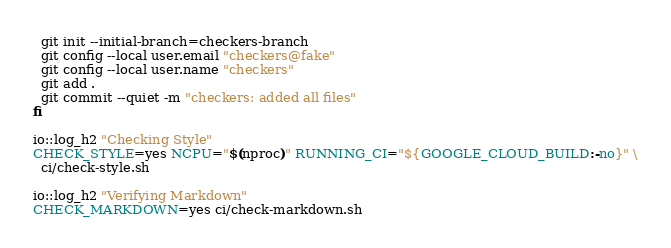Convert code to text. <code><loc_0><loc_0><loc_500><loc_500><_Bash_>  git init --initial-branch=checkers-branch
  git config --local user.email "checkers@fake"
  git config --local user.name "checkers"
  git add .
  git commit --quiet -m "checkers: added all files"
fi

io::log_h2 "Checking Style"
CHECK_STYLE=yes NCPU="$(nproc)" RUNNING_CI="${GOOGLE_CLOUD_BUILD:-no}" \
  ci/check-style.sh

io::log_h2 "Verifying Markdown"
CHECK_MARKDOWN=yes ci/check-markdown.sh
</code> 